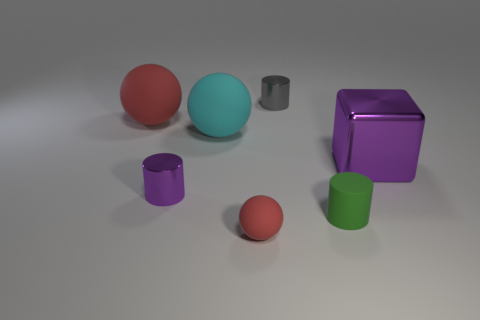Subtract all small rubber balls. How many balls are left? 2 Add 3 rubber cylinders. How many objects exist? 10 Subtract all spheres. How many objects are left? 4 Add 3 big purple shiny things. How many big purple shiny things are left? 4 Add 7 cyan metal balls. How many cyan metal balls exist? 7 Subtract 0 blue cylinders. How many objects are left? 7 Subtract all small blue shiny cubes. Subtract all purple objects. How many objects are left? 5 